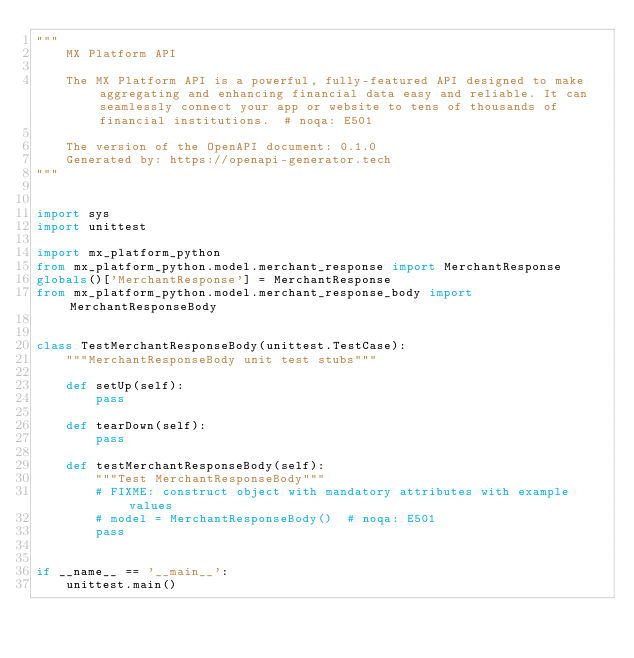<code> <loc_0><loc_0><loc_500><loc_500><_Python_>"""
    MX Platform API

    The MX Platform API is a powerful, fully-featured API designed to make aggregating and enhancing financial data easy and reliable. It can seamlessly connect your app or website to tens of thousands of financial institutions.  # noqa: E501

    The version of the OpenAPI document: 0.1.0
    Generated by: https://openapi-generator.tech
"""


import sys
import unittest

import mx_platform_python
from mx_platform_python.model.merchant_response import MerchantResponse
globals()['MerchantResponse'] = MerchantResponse
from mx_platform_python.model.merchant_response_body import MerchantResponseBody


class TestMerchantResponseBody(unittest.TestCase):
    """MerchantResponseBody unit test stubs"""

    def setUp(self):
        pass

    def tearDown(self):
        pass

    def testMerchantResponseBody(self):
        """Test MerchantResponseBody"""
        # FIXME: construct object with mandatory attributes with example values
        # model = MerchantResponseBody()  # noqa: E501
        pass


if __name__ == '__main__':
    unittest.main()
</code> 